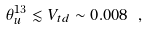Convert formula to latex. <formula><loc_0><loc_0><loc_500><loc_500>\theta _ { u } ^ { 1 3 } \lesssim V _ { t d } \sim 0 . 0 0 8 \ ,</formula> 